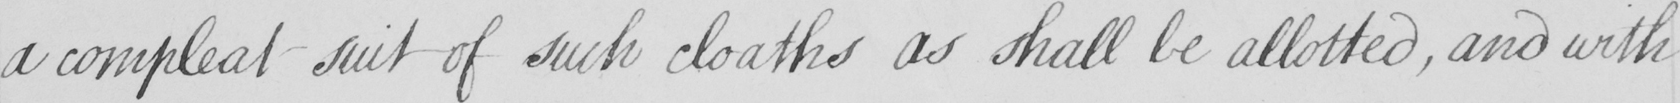Please transcribe the handwritten text in this image. a compleat suit of such cloaths as shall be allotted , and with 